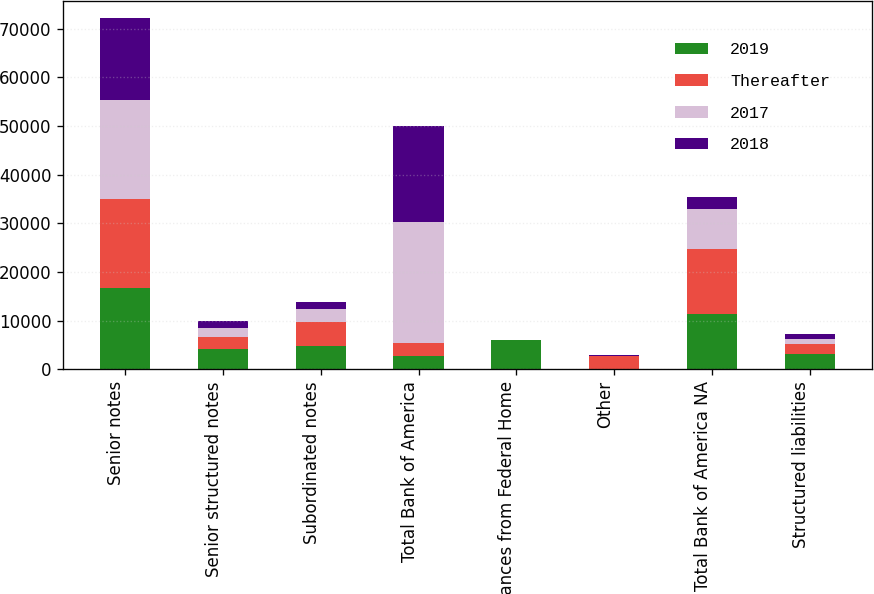<chart> <loc_0><loc_0><loc_500><loc_500><stacked_bar_chart><ecel><fcel>Senior notes<fcel>Senior structured notes<fcel>Subordinated notes<fcel>Total Bank of America<fcel>Advances from Federal Home<fcel>Other<fcel>Total Bank of America NA<fcel>Structured liabilities<nl><fcel>2019<fcel>16777<fcel>4230<fcel>4861<fcel>2695<fcel>6003<fcel>53<fcel>11450<fcel>3110<nl><fcel>Thereafter<fcel>18303<fcel>2352<fcel>4885<fcel>2695<fcel>10<fcel>2713<fcel>13368<fcel>2029<nl><fcel>2017<fcel>20211<fcel>1942<fcel>2677<fcel>24830<fcel>10<fcel>76<fcel>8095<fcel>1175<nl><fcel>2018<fcel>16820<fcel>1374<fcel>1479<fcel>19673<fcel>15<fcel>85<fcel>2551<fcel>882<nl></chart> 